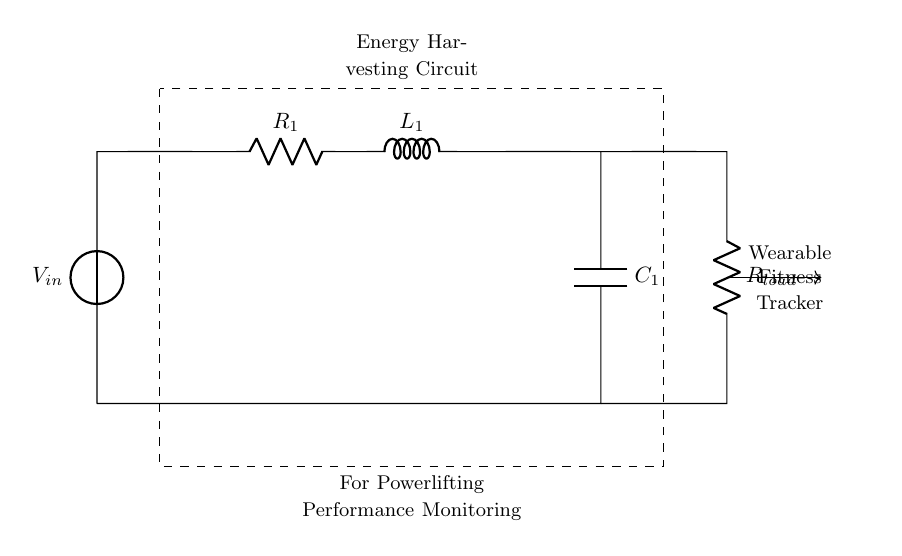What is the input voltage of this circuit? The circuit diagram shows a voltage source labeled as V_in, which represents the input voltage. Without a numerical value indicated in the diagram, it is not possible to specify an exact voltage. Therefore, we denote it as V_in.
Answer: V_in What are the components present in the energy harvesting circuit? The circuit diagram includes a voltage source (V_in), a resistor (R_1), an inductor (L_1), a capacitor (C_1), and a load resistor (R_load). By identifying each labeled component in the diagram, we can compile this list.
Answer: Voltage source, resistor, inductor, capacitor, load resistor What is the purpose of the capacitor in this circuit? The capacitor (C_1) stores electrical energy and smooths the output voltage to the load resistor. It plays a critical role in energy harvesting by storing the energy collected from the input and releasing it for use.
Answer: Store energy What is the function of the inductor in this circuit? The inductor (L_1) serves to store energy in a magnetic field when current flows through it. Its presence contributes to the energy management within the circuit by affecting the current and its response to changes in voltage.
Answer: Store energy in a magnetic field How many energy storage components are in this circuit? The circuit has two energy storage components: an inductor (L_1) and a capacitor (C_1). This is determined by identifying the components that can store energy within the circuit.
Answer: Two What is the relationship between the resistor and the load in this circuit? The load resistor (R_load) is connected in parallel with the capacitor (C_1), and it is responsible for consuming the power generated by this energy harvesting circuit. The current passes through the load resistor after being influenced by the preceding components.
Answer: Power consumption 